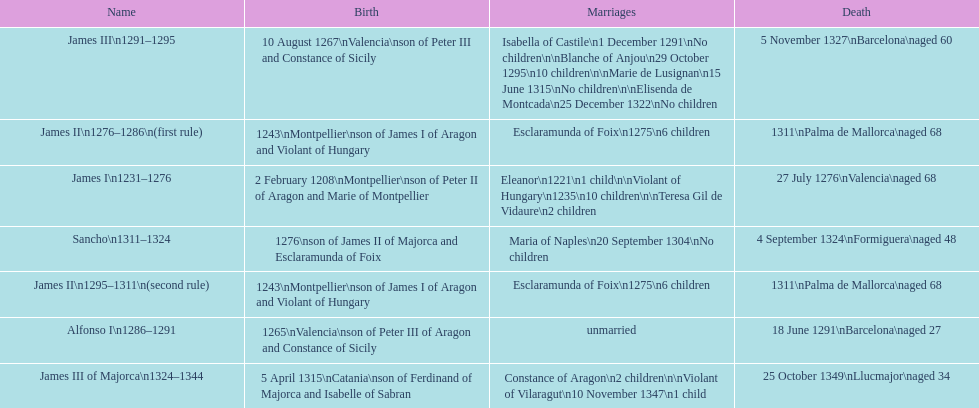Which monarch had the most marriages? James III 1291-1295. 